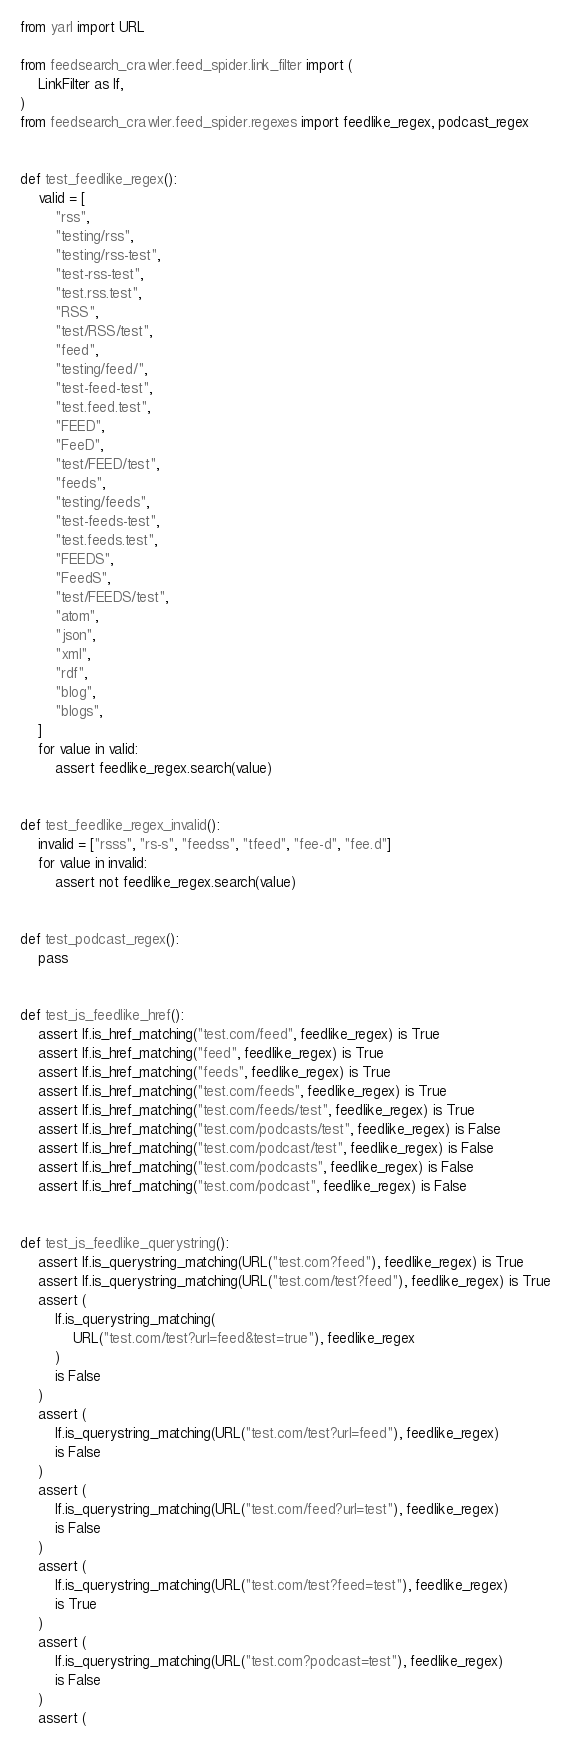<code> <loc_0><loc_0><loc_500><loc_500><_Python_>from yarl import URL

from feedsearch_crawler.feed_spider.link_filter import (
    LinkFilter as lf,
)
from feedsearch_crawler.feed_spider.regexes import feedlike_regex, podcast_regex


def test_feedlike_regex():
    valid = [
        "rss",
        "testing/rss",
        "testing/rss-test",
        "test-rss-test",
        "test.rss.test",
        "RSS",
        "test/RSS/test",
        "feed",
        "testing/feed/",
        "test-feed-test",
        "test.feed.test",
        "FEED",
        "FeeD",
        "test/FEED/test",
        "feeds",
        "testing/feeds",
        "test-feeds-test",
        "test.feeds.test",
        "FEEDS",
        "FeedS",
        "test/FEEDS/test",
        "atom",
        "json",
        "xml",
        "rdf",
        "blog",
        "blogs",
    ]
    for value in valid:
        assert feedlike_regex.search(value)


def test_feedlike_regex_invalid():
    invalid = ["rsss", "rs-s", "feedss", "tfeed", "fee-d", "fee.d"]
    for value in invalid:
        assert not feedlike_regex.search(value)


def test_podcast_regex():
    pass


def test_is_feedlike_href():
    assert lf.is_href_matching("test.com/feed", feedlike_regex) is True
    assert lf.is_href_matching("feed", feedlike_regex) is True
    assert lf.is_href_matching("feeds", feedlike_regex) is True
    assert lf.is_href_matching("test.com/feeds", feedlike_regex) is True
    assert lf.is_href_matching("test.com/feeds/test", feedlike_regex) is True
    assert lf.is_href_matching("test.com/podcasts/test", feedlike_regex) is False
    assert lf.is_href_matching("test.com/podcast/test", feedlike_regex) is False
    assert lf.is_href_matching("test.com/podcasts", feedlike_regex) is False
    assert lf.is_href_matching("test.com/podcast", feedlike_regex) is False


def test_is_feedlike_querystring():
    assert lf.is_querystring_matching(URL("test.com?feed"), feedlike_regex) is True
    assert lf.is_querystring_matching(URL("test.com/test?feed"), feedlike_regex) is True
    assert (
        lf.is_querystring_matching(
            URL("test.com/test?url=feed&test=true"), feedlike_regex
        )
        is False
    )
    assert (
        lf.is_querystring_matching(URL("test.com/test?url=feed"), feedlike_regex)
        is False
    )
    assert (
        lf.is_querystring_matching(URL("test.com/feed?url=test"), feedlike_regex)
        is False
    )
    assert (
        lf.is_querystring_matching(URL("test.com/test?feed=test"), feedlike_regex)
        is True
    )
    assert (
        lf.is_querystring_matching(URL("test.com?podcast=test"), feedlike_regex)
        is False
    )
    assert (</code> 